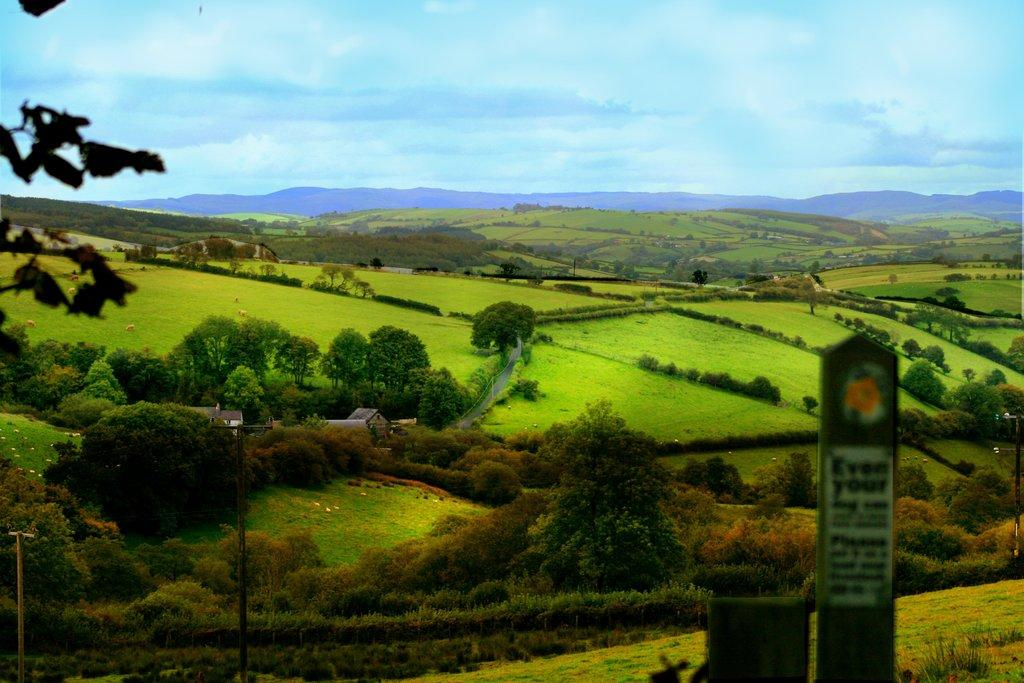What is the main object in the image? There is a board in the image. What can be seen in the background of the image? Planets, houses, mountains, and the sky are visible in the background of the image. How many tomatoes are on the board in the image? There are no tomatoes present in the image. What type of bikes can be seen in the image? There are no bikes present in the image. 